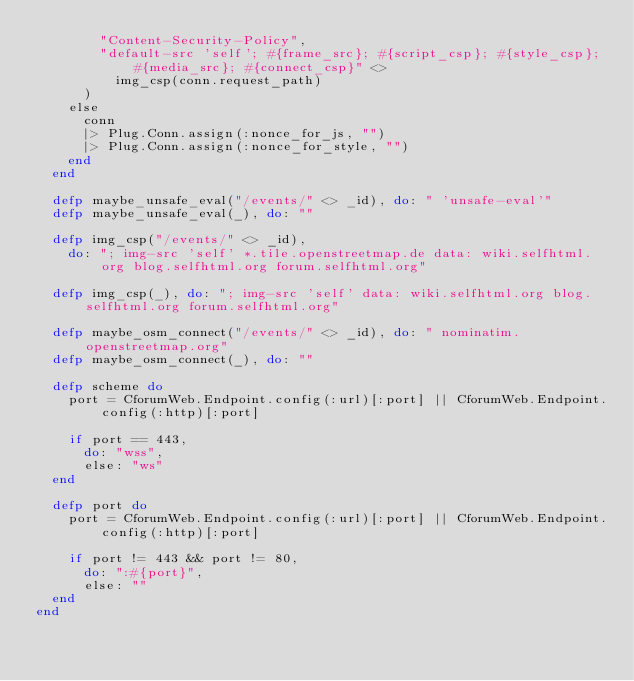<code> <loc_0><loc_0><loc_500><loc_500><_Elixir_>        "Content-Security-Policy",
        "default-src 'self'; #{frame_src}; #{script_csp}; #{style_csp}; #{media_src}; #{connect_csp}" <>
          img_csp(conn.request_path)
      )
    else
      conn
      |> Plug.Conn.assign(:nonce_for_js, "")
      |> Plug.Conn.assign(:nonce_for_style, "")
    end
  end

  defp maybe_unsafe_eval("/events/" <> _id), do: " 'unsafe-eval'"
  defp maybe_unsafe_eval(_), do: ""

  defp img_csp("/events/" <> _id),
    do: "; img-src 'self' *.tile.openstreetmap.de data: wiki.selfhtml.org blog.selfhtml.org forum.selfhtml.org"

  defp img_csp(_), do: "; img-src 'self' data: wiki.selfhtml.org blog.selfhtml.org forum.selfhtml.org"

  defp maybe_osm_connect("/events/" <> _id), do: " nominatim.openstreetmap.org"
  defp maybe_osm_connect(_), do: ""

  defp scheme do
    port = CforumWeb.Endpoint.config(:url)[:port] || CforumWeb.Endpoint.config(:http)[:port]

    if port == 443,
      do: "wss",
      else: "ws"
  end

  defp port do
    port = CforumWeb.Endpoint.config(:url)[:port] || CforumWeb.Endpoint.config(:http)[:port]

    if port != 443 && port != 80,
      do: ":#{port}",
      else: ""
  end
end
</code> 